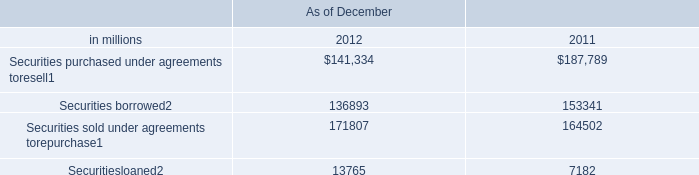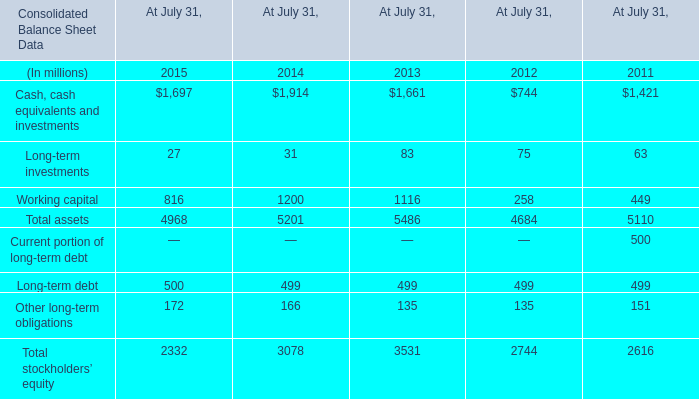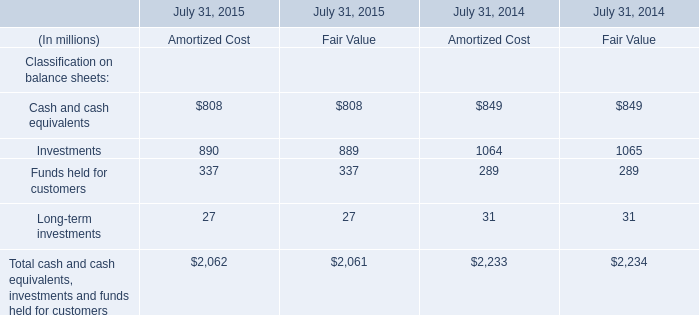What is the sum of Investments of July 31, 2014 Amortized Cost, Working capital of At July 31, 2013, and Securities borrowed of As of December 2012 ? 
Computations: ((1064.0 + 1116.0) + 136893.0)
Answer: 139073.0. 